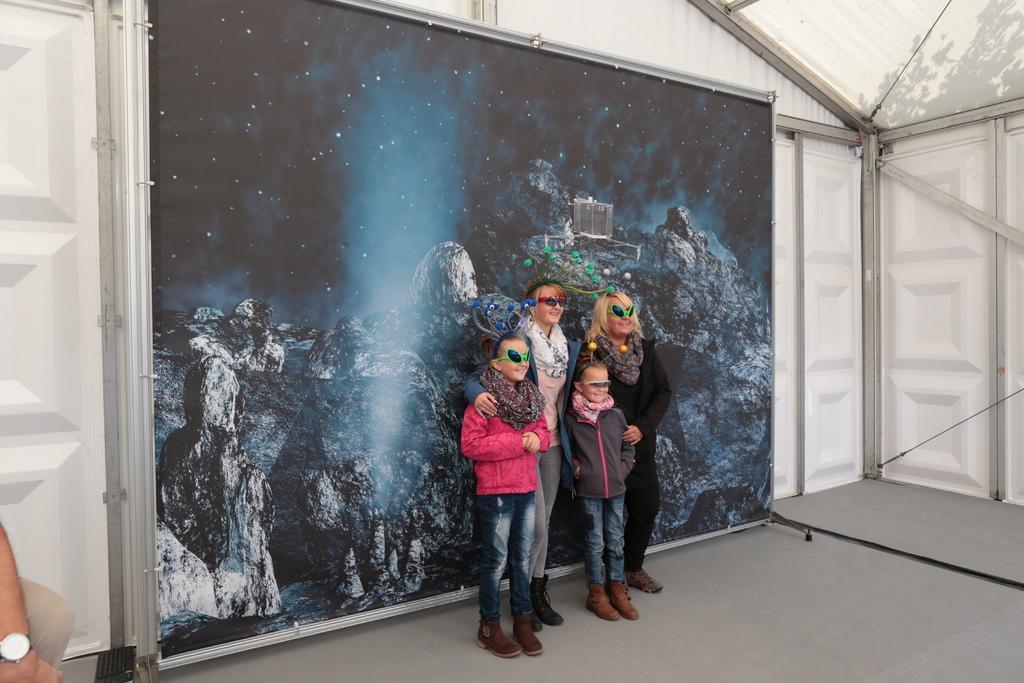Could you give a brief overview of what you see in this image? In this image we can see the people standing on the floor. In the background, we can see the board with painting. And there are doors on both sides. 